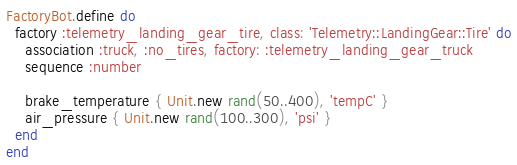Convert code to text. <code><loc_0><loc_0><loc_500><loc_500><_Ruby_>FactoryBot.define do
  factory :telemetry_landing_gear_tire, class: 'Telemetry::LandingGear::Tire' do
    association :truck, :no_tires, factory: :telemetry_landing_gear_truck
    sequence :number

    brake_temperature { Unit.new rand(50..400), 'tempC' }
    air_pressure { Unit.new rand(100..300), 'psi' }
  end
end
</code> 